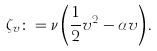<formula> <loc_0><loc_0><loc_500><loc_500>\zeta _ { v } \colon = \nu \left ( \frac { 1 } { 2 } v ^ { 2 } - \alpha v \right ) .</formula> 